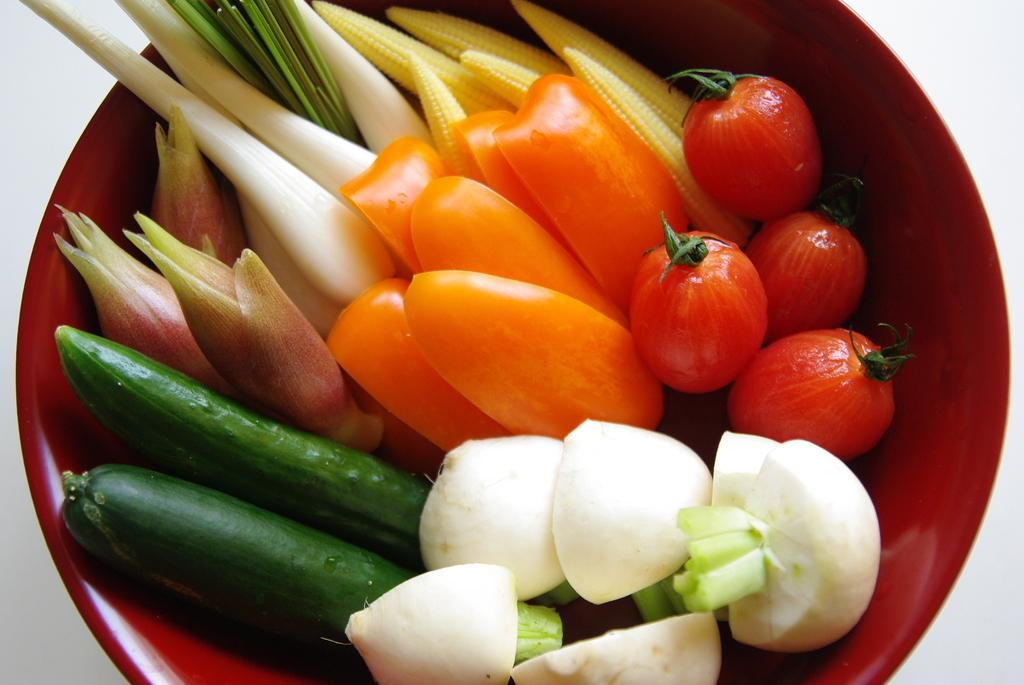What is in the bowl that is visible in the image? There is a bowl containing vegetables in the image. What specific types of vegetables are included in the bowl? The vegetables include baby corn, tomatoes, cucumber, and buds. Can you see a tiger walking through the door in the image? There is no tiger or door present in the image; it features a bowl of vegetables. 